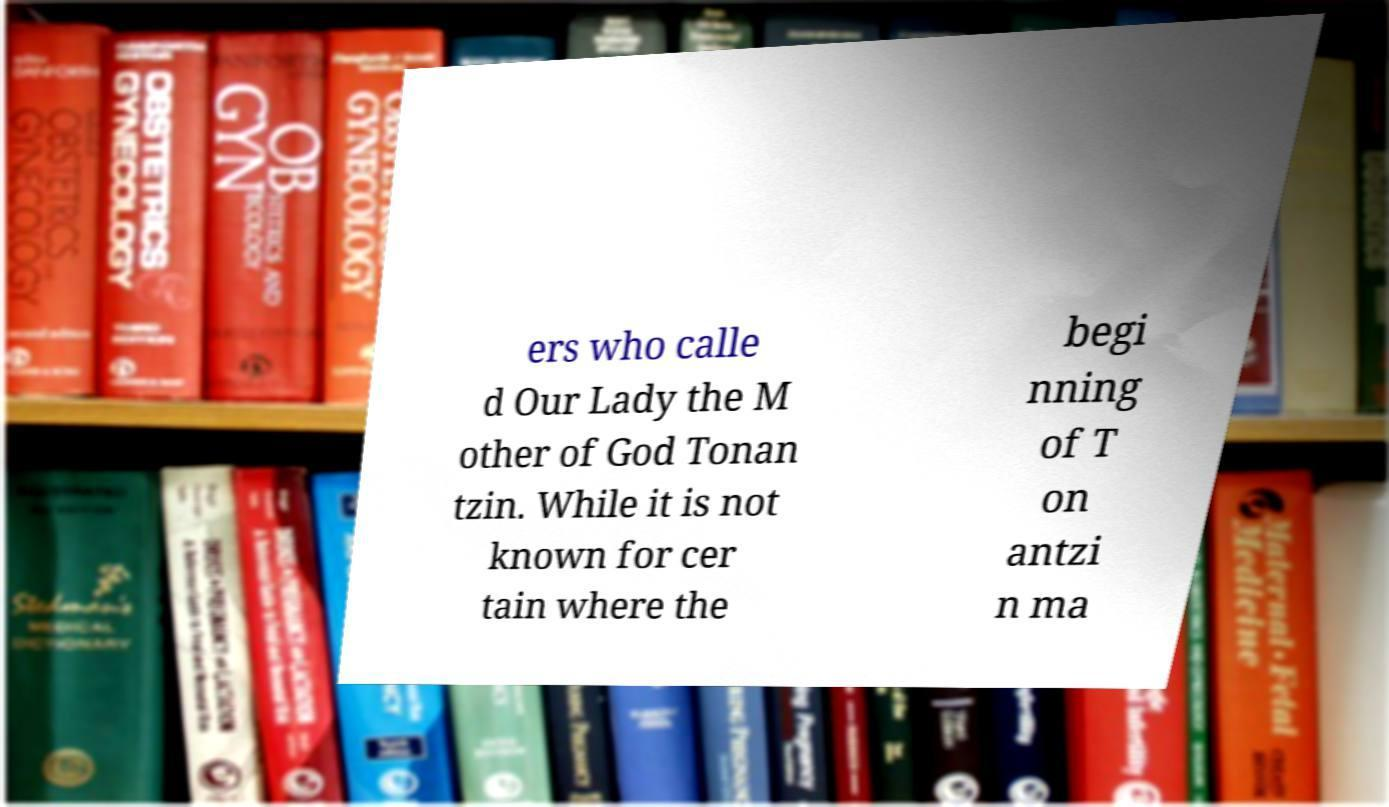Please identify and transcribe the text found in this image. ers who calle d Our Lady the M other of God Tonan tzin. While it is not known for cer tain where the begi nning of T on antzi n ma 